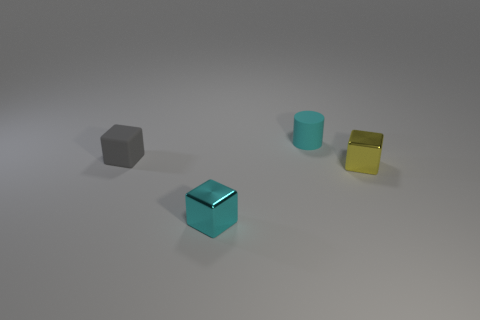What is the material of the cylinder that is the same size as the gray object?
Offer a terse response. Rubber. What is the color of the tiny object that is to the left of the cyan matte thing and in front of the tiny gray rubber cube?
Your response must be concise. Cyan. How many objects are tiny metal cubes that are in front of the cyan matte thing or small gray cubes?
Your answer should be compact. 3. How many other objects are the same color as the small matte cylinder?
Provide a short and direct response. 1. Are there an equal number of small rubber things that are to the right of the cyan metal block and small cyan cylinders?
Offer a very short reply. Yes. There is a small rubber thing that is on the right side of the matte object in front of the tiny cylinder; what number of small cyan cylinders are right of it?
Your answer should be very brief. 0. What number of small metal things are there?
Offer a terse response. 2. There is another metal object that is the same shape as the tiny yellow object; what color is it?
Make the answer very short. Cyan. Do the small yellow object and the small gray rubber thing have the same shape?
Give a very brief answer. Yes. What number of small gray blocks are made of the same material as the yellow block?
Your answer should be compact. 0. 